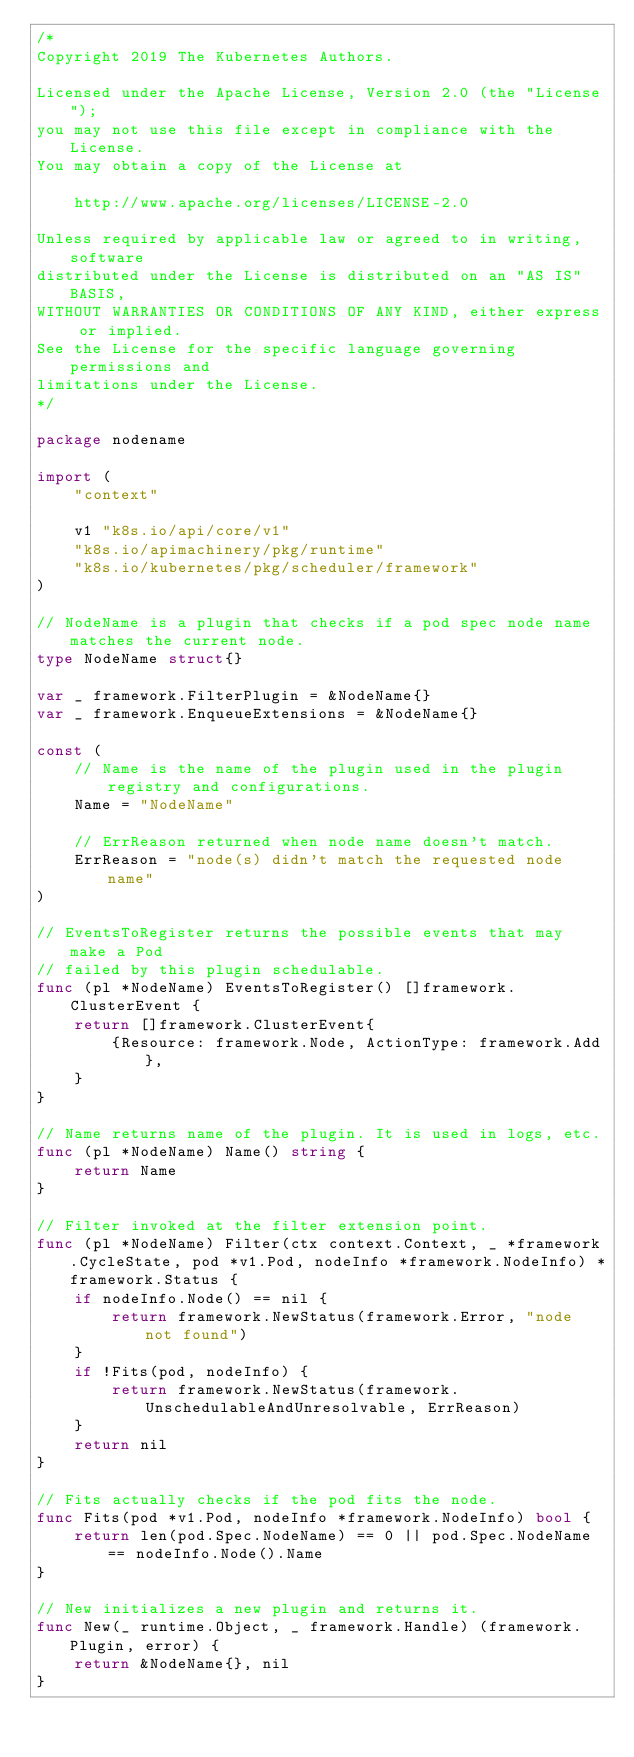Convert code to text. <code><loc_0><loc_0><loc_500><loc_500><_Go_>/*
Copyright 2019 The Kubernetes Authors.

Licensed under the Apache License, Version 2.0 (the "License");
you may not use this file except in compliance with the License.
You may obtain a copy of the License at

    http://www.apache.org/licenses/LICENSE-2.0

Unless required by applicable law or agreed to in writing, software
distributed under the License is distributed on an "AS IS" BASIS,
WITHOUT WARRANTIES OR CONDITIONS OF ANY KIND, either express or implied.
See the License for the specific language governing permissions and
limitations under the License.
*/

package nodename

import (
	"context"

	v1 "k8s.io/api/core/v1"
	"k8s.io/apimachinery/pkg/runtime"
	"k8s.io/kubernetes/pkg/scheduler/framework"
)

// NodeName is a plugin that checks if a pod spec node name matches the current node.
type NodeName struct{}

var _ framework.FilterPlugin = &NodeName{}
var _ framework.EnqueueExtensions = &NodeName{}

const (
	// Name is the name of the plugin used in the plugin registry and configurations.
	Name = "NodeName"

	// ErrReason returned when node name doesn't match.
	ErrReason = "node(s) didn't match the requested node name"
)

// EventsToRegister returns the possible events that may make a Pod
// failed by this plugin schedulable.
func (pl *NodeName) EventsToRegister() []framework.ClusterEvent {
	return []framework.ClusterEvent{
		{Resource: framework.Node, ActionType: framework.Add},
	}
}

// Name returns name of the plugin. It is used in logs, etc.
func (pl *NodeName) Name() string {
	return Name
}

// Filter invoked at the filter extension point.
func (pl *NodeName) Filter(ctx context.Context, _ *framework.CycleState, pod *v1.Pod, nodeInfo *framework.NodeInfo) *framework.Status {
	if nodeInfo.Node() == nil {
		return framework.NewStatus(framework.Error, "node not found")
	}
	if !Fits(pod, nodeInfo) {
		return framework.NewStatus(framework.UnschedulableAndUnresolvable, ErrReason)
	}
	return nil
}

// Fits actually checks if the pod fits the node.
func Fits(pod *v1.Pod, nodeInfo *framework.NodeInfo) bool {
	return len(pod.Spec.NodeName) == 0 || pod.Spec.NodeName == nodeInfo.Node().Name
}

// New initializes a new plugin and returns it.
func New(_ runtime.Object, _ framework.Handle) (framework.Plugin, error) {
	return &NodeName{}, nil
}
</code> 